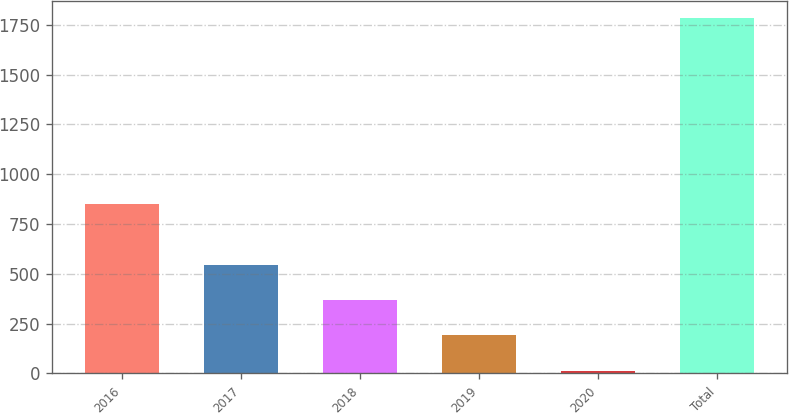Convert chart to OTSL. <chart><loc_0><loc_0><loc_500><loc_500><bar_chart><fcel>2016<fcel>2017<fcel>2018<fcel>2019<fcel>2020<fcel>Total<nl><fcel>850<fcel>545.4<fcel>368.6<fcel>191.8<fcel>15<fcel>1783<nl></chart> 